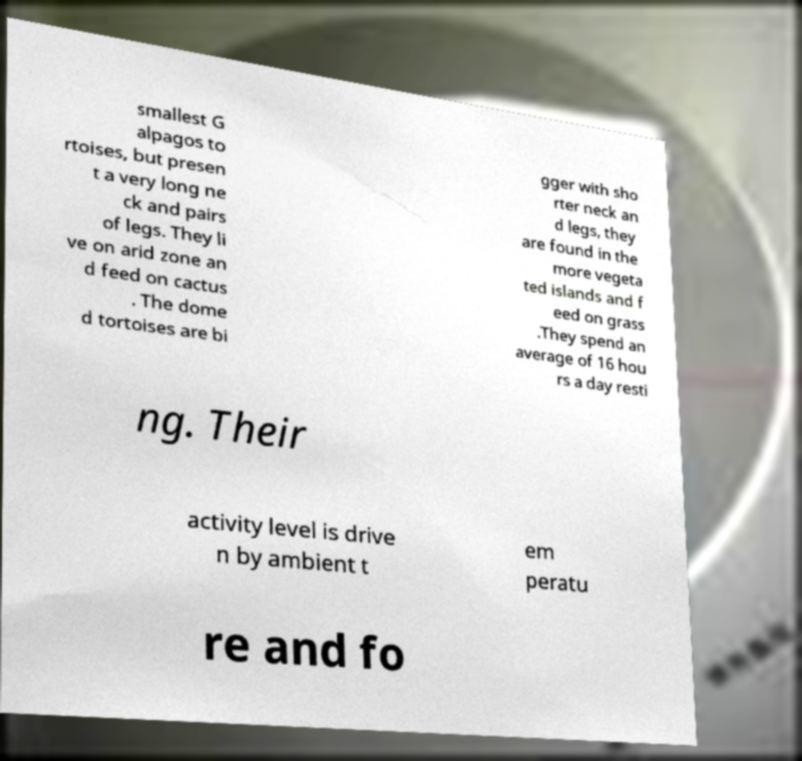Please read and relay the text visible in this image. What does it say? smallest G alpagos to rtoises, but presen t a very long ne ck and pairs of legs. They li ve on arid zone an d feed on cactus . The dome d tortoises are bi gger with sho rter neck an d legs, they are found in the more vegeta ted islands and f eed on grass .They spend an average of 16 hou rs a day resti ng. Their activity level is drive n by ambient t em peratu re and fo 